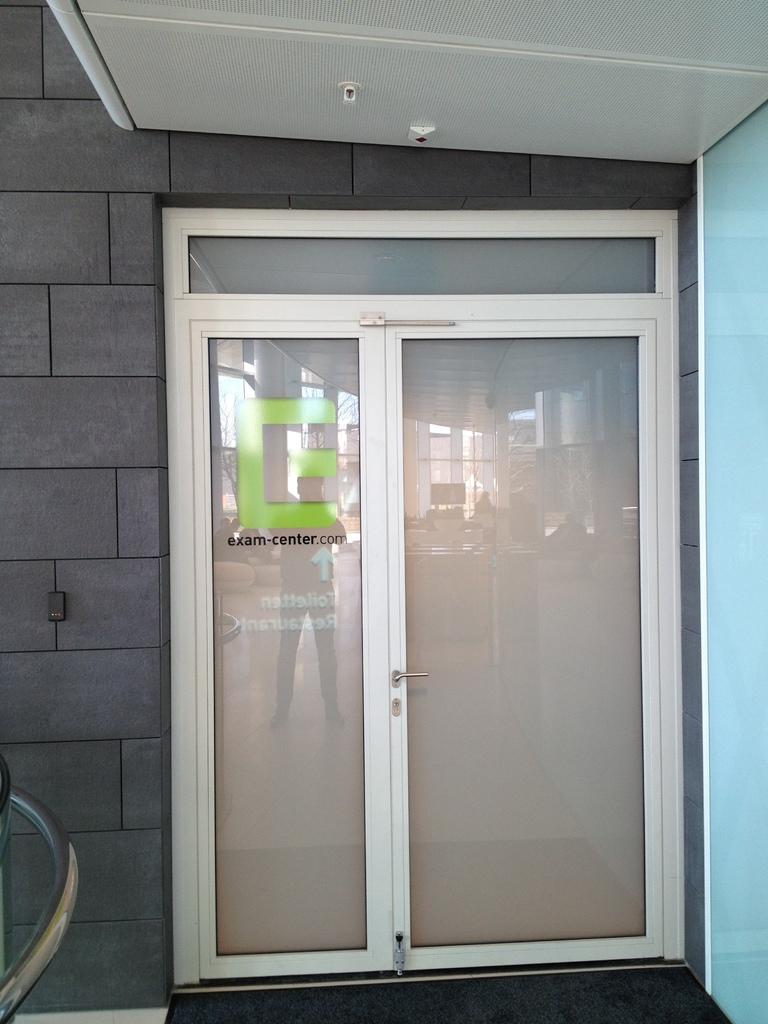What type of door is visible in the image? There is a glass door in the image. What can be seen on the left side of the image? There are black cladding tiles on the left side of the image. Can you see any airplanes taking off from the airport in the image? There is no airport or airplanes present in the image. What type of cracker is floating in the water in the image? There is no cracker or water present in the image. 